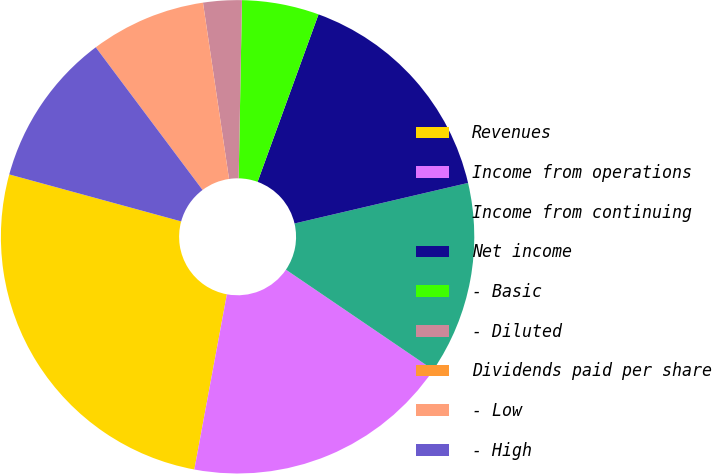Convert chart to OTSL. <chart><loc_0><loc_0><loc_500><loc_500><pie_chart><fcel>Revenues<fcel>Income from operations<fcel>Income from continuing<fcel>Net income<fcel>- Basic<fcel>- Diluted<fcel>Dividends paid per share<fcel>- Low<fcel>- High<nl><fcel>26.32%<fcel>18.42%<fcel>13.16%<fcel>15.79%<fcel>5.26%<fcel>2.63%<fcel>0.0%<fcel>7.89%<fcel>10.53%<nl></chart> 